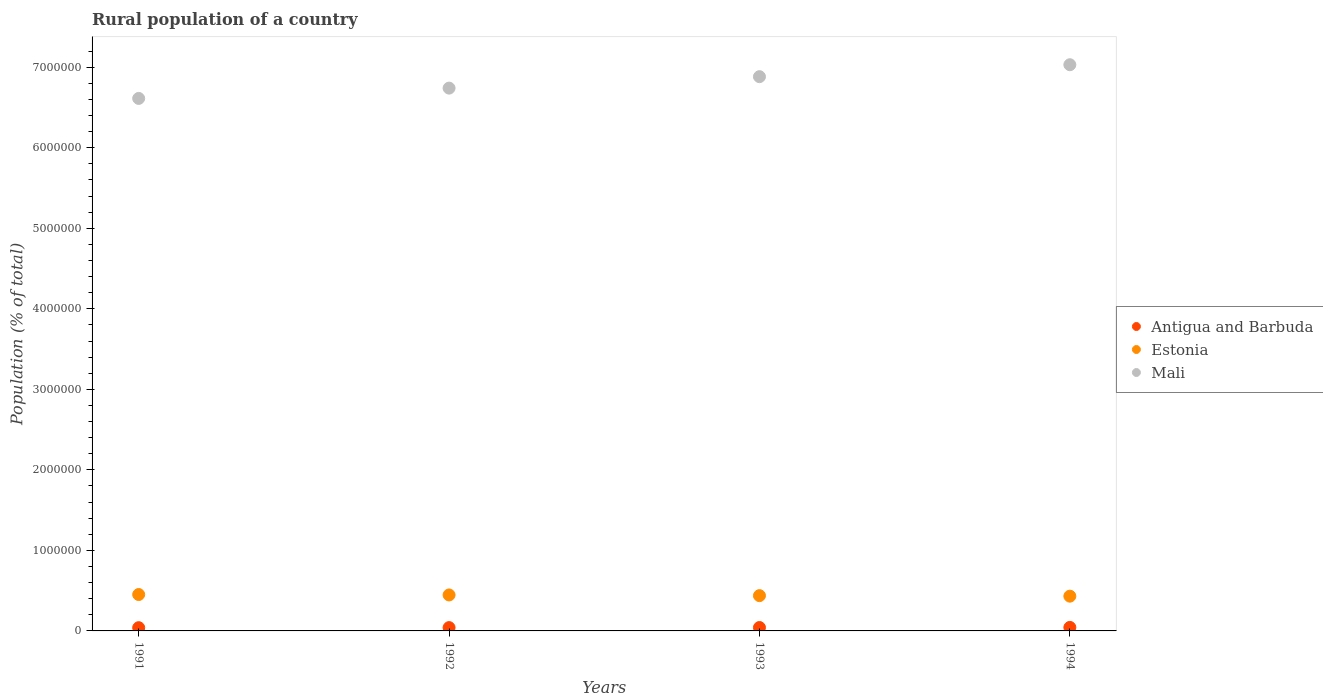How many different coloured dotlines are there?
Your answer should be very brief. 3. What is the rural population in Mali in 1994?
Offer a very short reply. 7.03e+06. Across all years, what is the maximum rural population in Mali?
Keep it short and to the point. 7.03e+06. Across all years, what is the minimum rural population in Mali?
Make the answer very short. 6.61e+06. What is the total rural population in Antigua and Barbuda in the graph?
Provide a succinct answer. 1.68e+05. What is the difference between the rural population in Estonia in 1992 and that in 1993?
Make the answer very short. 8575. What is the difference between the rural population in Mali in 1993 and the rural population in Antigua and Barbuda in 1991?
Offer a very short reply. 6.84e+06. What is the average rural population in Estonia per year?
Your answer should be very brief. 4.42e+05. In the year 1994, what is the difference between the rural population in Mali and rural population in Estonia?
Ensure brevity in your answer.  6.60e+06. What is the ratio of the rural population in Antigua and Barbuda in 1991 to that in 1994?
Your answer should be very brief. 0.92. Is the difference between the rural population in Mali in 1992 and 1993 greater than the difference between the rural population in Estonia in 1992 and 1993?
Give a very brief answer. No. What is the difference between the highest and the second highest rural population in Antigua and Barbuda?
Provide a succinct answer. 1348. What is the difference between the highest and the lowest rural population in Mali?
Make the answer very short. 4.18e+05. In how many years, is the rural population in Antigua and Barbuda greater than the average rural population in Antigua and Barbuda taken over all years?
Offer a terse response. 2. Is the sum of the rural population in Mali in 1991 and 1994 greater than the maximum rural population in Antigua and Barbuda across all years?
Make the answer very short. Yes. Is it the case that in every year, the sum of the rural population in Mali and rural population in Antigua and Barbuda  is greater than the rural population in Estonia?
Offer a very short reply. Yes. Does the rural population in Mali monotonically increase over the years?
Keep it short and to the point. Yes. Is the rural population in Estonia strictly less than the rural population in Mali over the years?
Your answer should be very brief. Yes. How many dotlines are there?
Your answer should be very brief. 3. How many years are there in the graph?
Your answer should be very brief. 4. Are the values on the major ticks of Y-axis written in scientific E-notation?
Provide a succinct answer. No. Does the graph contain grids?
Make the answer very short. No. How many legend labels are there?
Provide a short and direct response. 3. What is the title of the graph?
Give a very brief answer. Rural population of a country. Does "Turkey" appear as one of the legend labels in the graph?
Your answer should be very brief. No. What is the label or title of the Y-axis?
Offer a terse response. Population (% of total). What is the Population (% of total) of Antigua and Barbuda in 1991?
Keep it short and to the point. 4.03e+04. What is the Population (% of total) in Estonia in 1991?
Provide a succinct answer. 4.52e+05. What is the Population (% of total) of Mali in 1991?
Your response must be concise. 6.61e+06. What is the Population (% of total) in Antigua and Barbuda in 1992?
Your answer should be very brief. 4.12e+04. What is the Population (% of total) in Estonia in 1992?
Your answer should be very brief. 4.47e+05. What is the Population (% of total) of Mali in 1992?
Provide a short and direct response. 6.74e+06. What is the Population (% of total) in Antigua and Barbuda in 1993?
Your response must be concise. 4.24e+04. What is the Population (% of total) of Estonia in 1993?
Make the answer very short. 4.38e+05. What is the Population (% of total) of Mali in 1993?
Give a very brief answer. 6.88e+06. What is the Population (% of total) in Antigua and Barbuda in 1994?
Offer a very short reply. 4.37e+04. What is the Population (% of total) in Estonia in 1994?
Keep it short and to the point. 4.32e+05. What is the Population (% of total) of Mali in 1994?
Offer a terse response. 7.03e+06. Across all years, what is the maximum Population (% of total) in Antigua and Barbuda?
Keep it short and to the point. 4.37e+04. Across all years, what is the maximum Population (% of total) in Estonia?
Make the answer very short. 4.52e+05. Across all years, what is the maximum Population (% of total) of Mali?
Offer a terse response. 7.03e+06. Across all years, what is the minimum Population (% of total) in Antigua and Barbuda?
Provide a short and direct response. 4.03e+04. Across all years, what is the minimum Population (% of total) of Estonia?
Offer a very short reply. 4.32e+05. Across all years, what is the minimum Population (% of total) of Mali?
Ensure brevity in your answer.  6.61e+06. What is the total Population (% of total) of Antigua and Barbuda in the graph?
Give a very brief answer. 1.68e+05. What is the total Population (% of total) in Estonia in the graph?
Your answer should be compact. 1.77e+06. What is the total Population (% of total) of Mali in the graph?
Give a very brief answer. 2.73e+07. What is the difference between the Population (% of total) in Antigua and Barbuda in 1991 and that in 1992?
Offer a terse response. -900. What is the difference between the Population (% of total) of Estonia in 1991 and that in 1992?
Provide a succinct answer. 5320. What is the difference between the Population (% of total) of Mali in 1991 and that in 1992?
Your answer should be very brief. -1.28e+05. What is the difference between the Population (% of total) of Antigua and Barbuda in 1991 and that in 1993?
Make the answer very short. -2075. What is the difference between the Population (% of total) of Estonia in 1991 and that in 1993?
Your answer should be very brief. 1.39e+04. What is the difference between the Population (% of total) in Mali in 1991 and that in 1993?
Ensure brevity in your answer.  -2.70e+05. What is the difference between the Population (% of total) in Antigua and Barbuda in 1991 and that in 1994?
Provide a succinct answer. -3423. What is the difference between the Population (% of total) in Estonia in 1991 and that in 1994?
Provide a short and direct response. 2.04e+04. What is the difference between the Population (% of total) of Mali in 1991 and that in 1994?
Offer a very short reply. -4.18e+05. What is the difference between the Population (% of total) in Antigua and Barbuda in 1992 and that in 1993?
Offer a terse response. -1175. What is the difference between the Population (% of total) of Estonia in 1992 and that in 1993?
Your response must be concise. 8575. What is the difference between the Population (% of total) in Mali in 1992 and that in 1993?
Provide a succinct answer. -1.42e+05. What is the difference between the Population (% of total) of Antigua and Barbuda in 1992 and that in 1994?
Make the answer very short. -2523. What is the difference between the Population (% of total) in Estonia in 1992 and that in 1994?
Your response must be concise. 1.51e+04. What is the difference between the Population (% of total) in Mali in 1992 and that in 1994?
Give a very brief answer. -2.91e+05. What is the difference between the Population (% of total) in Antigua and Barbuda in 1993 and that in 1994?
Your answer should be compact. -1348. What is the difference between the Population (% of total) of Estonia in 1993 and that in 1994?
Your response must be concise. 6536. What is the difference between the Population (% of total) in Mali in 1993 and that in 1994?
Provide a succinct answer. -1.48e+05. What is the difference between the Population (% of total) of Antigua and Barbuda in 1991 and the Population (% of total) of Estonia in 1992?
Ensure brevity in your answer.  -4.06e+05. What is the difference between the Population (% of total) of Antigua and Barbuda in 1991 and the Population (% of total) of Mali in 1992?
Offer a terse response. -6.70e+06. What is the difference between the Population (% of total) in Estonia in 1991 and the Population (% of total) in Mali in 1992?
Keep it short and to the point. -6.29e+06. What is the difference between the Population (% of total) of Antigua and Barbuda in 1991 and the Population (% of total) of Estonia in 1993?
Keep it short and to the point. -3.98e+05. What is the difference between the Population (% of total) of Antigua and Barbuda in 1991 and the Population (% of total) of Mali in 1993?
Provide a short and direct response. -6.84e+06. What is the difference between the Population (% of total) in Estonia in 1991 and the Population (% of total) in Mali in 1993?
Your response must be concise. -6.43e+06. What is the difference between the Population (% of total) in Antigua and Barbuda in 1991 and the Population (% of total) in Estonia in 1994?
Your answer should be compact. -3.91e+05. What is the difference between the Population (% of total) in Antigua and Barbuda in 1991 and the Population (% of total) in Mali in 1994?
Your answer should be very brief. -6.99e+06. What is the difference between the Population (% of total) of Estonia in 1991 and the Population (% of total) of Mali in 1994?
Keep it short and to the point. -6.58e+06. What is the difference between the Population (% of total) in Antigua and Barbuda in 1992 and the Population (% of total) in Estonia in 1993?
Provide a short and direct response. -3.97e+05. What is the difference between the Population (% of total) in Antigua and Barbuda in 1992 and the Population (% of total) in Mali in 1993?
Give a very brief answer. -6.84e+06. What is the difference between the Population (% of total) in Estonia in 1992 and the Population (% of total) in Mali in 1993?
Ensure brevity in your answer.  -6.44e+06. What is the difference between the Population (% of total) in Antigua and Barbuda in 1992 and the Population (% of total) in Estonia in 1994?
Keep it short and to the point. -3.90e+05. What is the difference between the Population (% of total) in Antigua and Barbuda in 1992 and the Population (% of total) in Mali in 1994?
Provide a succinct answer. -6.99e+06. What is the difference between the Population (% of total) of Estonia in 1992 and the Population (% of total) of Mali in 1994?
Make the answer very short. -6.58e+06. What is the difference between the Population (% of total) of Antigua and Barbuda in 1993 and the Population (% of total) of Estonia in 1994?
Keep it short and to the point. -3.89e+05. What is the difference between the Population (% of total) in Antigua and Barbuda in 1993 and the Population (% of total) in Mali in 1994?
Your answer should be compact. -6.99e+06. What is the difference between the Population (% of total) in Estonia in 1993 and the Population (% of total) in Mali in 1994?
Keep it short and to the point. -6.59e+06. What is the average Population (% of total) of Antigua and Barbuda per year?
Ensure brevity in your answer.  4.19e+04. What is the average Population (% of total) in Estonia per year?
Your answer should be very brief. 4.42e+05. What is the average Population (% of total) of Mali per year?
Your response must be concise. 6.82e+06. In the year 1991, what is the difference between the Population (% of total) in Antigua and Barbuda and Population (% of total) in Estonia?
Provide a short and direct response. -4.12e+05. In the year 1991, what is the difference between the Population (% of total) in Antigua and Barbuda and Population (% of total) in Mali?
Provide a succinct answer. -6.57e+06. In the year 1991, what is the difference between the Population (% of total) of Estonia and Population (% of total) of Mali?
Make the answer very short. -6.16e+06. In the year 1992, what is the difference between the Population (% of total) of Antigua and Barbuda and Population (% of total) of Estonia?
Offer a terse response. -4.06e+05. In the year 1992, what is the difference between the Population (% of total) of Antigua and Barbuda and Population (% of total) of Mali?
Keep it short and to the point. -6.70e+06. In the year 1992, what is the difference between the Population (% of total) of Estonia and Population (% of total) of Mali?
Give a very brief answer. -6.29e+06. In the year 1993, what is the difference between the Population (% of total) of Antigua and Barbuda and Population (% of total) of Estonia?
Ensure brevity in your answer.  -3.96e+05. In the year 1993, what is the difference between the Population (% of total) of Antigua and Barbuda and Population (% of total) of Mali?
Ensure brevity in your answer.  -6.84e+06. In the year 1993, what is the difference between the Population (% of total) in Estonia and Population (% of total) in Mali?
Your answer should be compact. -6.44e+06. In the year 1994, what is the difference between the Population (% of total) in Antigua and Barbuda and Population (% of total) in Estonia?
Keep it short and to the point. -3.88e+05. In the year 1994, what is the difference between the Population (% of total) of Antigua and Barbuda and Population (% of total) of Mali?
Your answer should be compact. -6.99e+06. In the year 1994, what is the difference between the Population (% of total) of Estonia and Population (% of total) of Mali?
Give a very brief answer. -6.60e+06. What is the ratio of the Population (% of total) in Antigua and Barbuda in 1991 to that in 1992?
Keep it short and to the point. 0.98. What is the ratio of the Population (% of total) of Estonia in 1991 to that in 1992?
Your response must be concise. 1.01. What is the ratio of the Population (% of total) in Antigua and Barbuda in 1991 to that in 1993?
Your answer should be very brief. 0.95. What is the ratio of the Population (% of total) in Estonia in 1991 to that in 1993?
Ensure brevity in your answer.  1.03. What is the ratio of the Population (% of total) of Mali in 1991 to that in 1993?
Keep it short and to the point. 0.96. What is the ratio of the Population (% of total) of Antigua and Barbuda in 1991 to that in 1994?
Make the answer very short. 0.92. What is the ratio of the Population (% of total) in Estonia in 1991 to that in 1994?
Offer a terse response. 1.05. What is the ratio of the Population (% of total) in Mali in 1991 to that in 1994?
Provide a short and direct response. 0.94. What is the ratio of the Population (% of total) in Antigua and Barbuda in 1992 to that in 1993?
Provide a short and direct response. 0.97. What is the ratio of the Population (% of total) of Estonia in 1992 to that in 1993?
Give a very brief answer. 1.02. What is the ratio of the Population (% of total) of Mali in 1992 to that in 1993?
Provide a succinct answer. 0.98. What is the ratio of the Population (% of total) of Antigua and Barbuda in 1992 to that in 1994?
Make the answer very short. 0.94. What is the ratio of the Population (% of total) of Estonia in 1992 to that in 1994?
Give a very brief answer. 1.03. What is the ratio of the Population (% of total) of Mali in 1992 to that in 1994?
Keep it short and to the point. 0.96. What is the ratio of the Population (% of total) of Antigua and Barbuda in 1993 to that in 1994?
Ensure brevity in your answer.  0.97. What is the ratio of the Population (% of total) in Estonia in 1993 to that in 1994?
Your answer should be compact. 1.02. What is the ratio of the Population (% of total) in Mali in 1993 to that in 1994?
Your response must be concise. 0.98. What is the difference between the highest and the second highest Population (% of total) in Antigua and Barbuda?
Your answer should be compact. 1348. What is the difference between the highest and the second highest Population (% of total) in Estonia?
Provide a short and direct response. 5320. What is the difference between the highest and the second highest Population (% of total) of Mali?
Provide a short and direct response. 1.48e+05. What is the difference between the highest and the lowest Population (% of total) of Antigua and Barbuda?
Your answer should be compact. 3423. What is the difference between the highest and the lowest Population (% of total) in Estonia?
Provide a succinct answer. 2.04e+04. What is the difference between the highest and the lowest Population (% of total) of Mali?
Make the answer very short. 4.18e+05. 